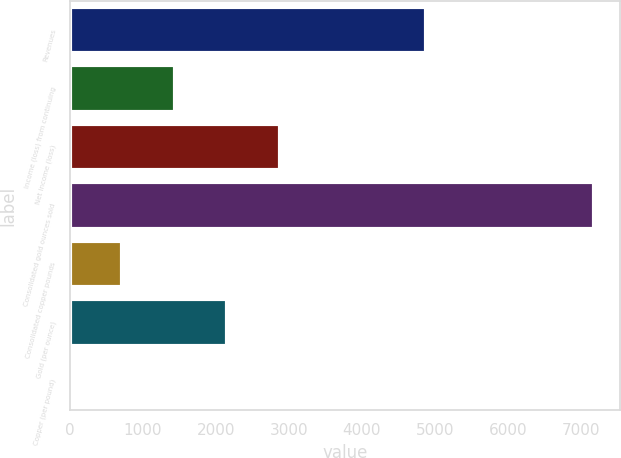Convert chart. <chart><loc_0><loc_0><loc_500><loc_500><bar_chart><fcel>Revenues<fcel>Income (loss) from continuing<fcel>Net income (loss)<fcel>Consolidated gold ounces sold<fcel>Consolidated copper pounds<fcel>Gold (per ounce)<fcel>Copper (per pound)<nl><fcel>4882<fcel>1438.44<fcel>2875.34<fcel>7186<fcel>719.99<fcel>2156.89<fcel>1.54<nl></chart> 